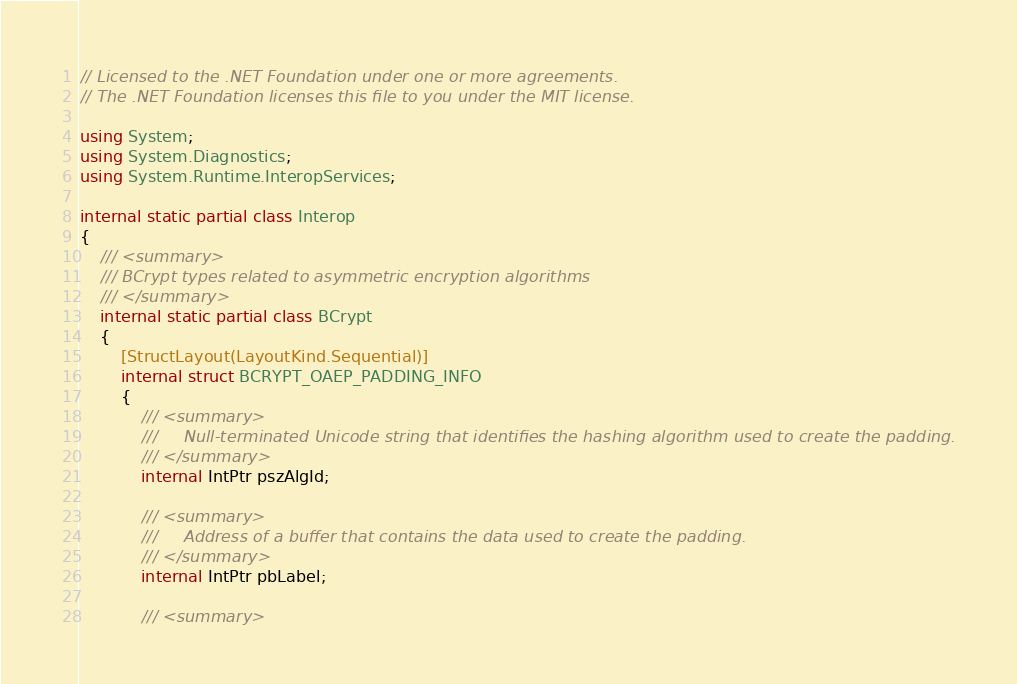<code> <loc_0><loc_0><loc_500><loc_500><_C#_>// Licensed to the .NET Foundation under one or more agreements.
// The .NET Foundation licenses this file to you under the MIT license.

using System;
using System.Diagnostics;
using System.Runtime.InteropServices;

internal static partial class Interop
{
    /// <summary>
    /// BCrypt types related to asymmetric encryption algorithms
    /// </summary>
    internal static partial class BCrypt
    {
        [StructLayout(LayoutKind.Sequential)]
        internal struct BCRYPT_OAEP_PADDING_INFO
        {
            /// <summary>
            ///     Null-terminated Unicode string that identifies the hashing algorithm used to create the padding.
            /// </summary>
            internal IntPtr pszAlgId;

            /// <summary>
            ///     Address of a buffer that contains the data used to create the padding.
            /// </summary>
            internal IntPtr pbLabel;

            /// <summary></code> 